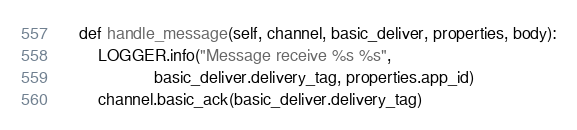<code> <loc_0><loc_0><loc_500><loc_500><_Python_>    def handle_message(self, channel, basic_deliver, properties, body):
        LOGGER.info("Message receive %s %s",
                    basic_deliver.delivery_tag, properties.app_id)
        channel.basic_ack(basic_deliver.delivery_tag)
</code> 